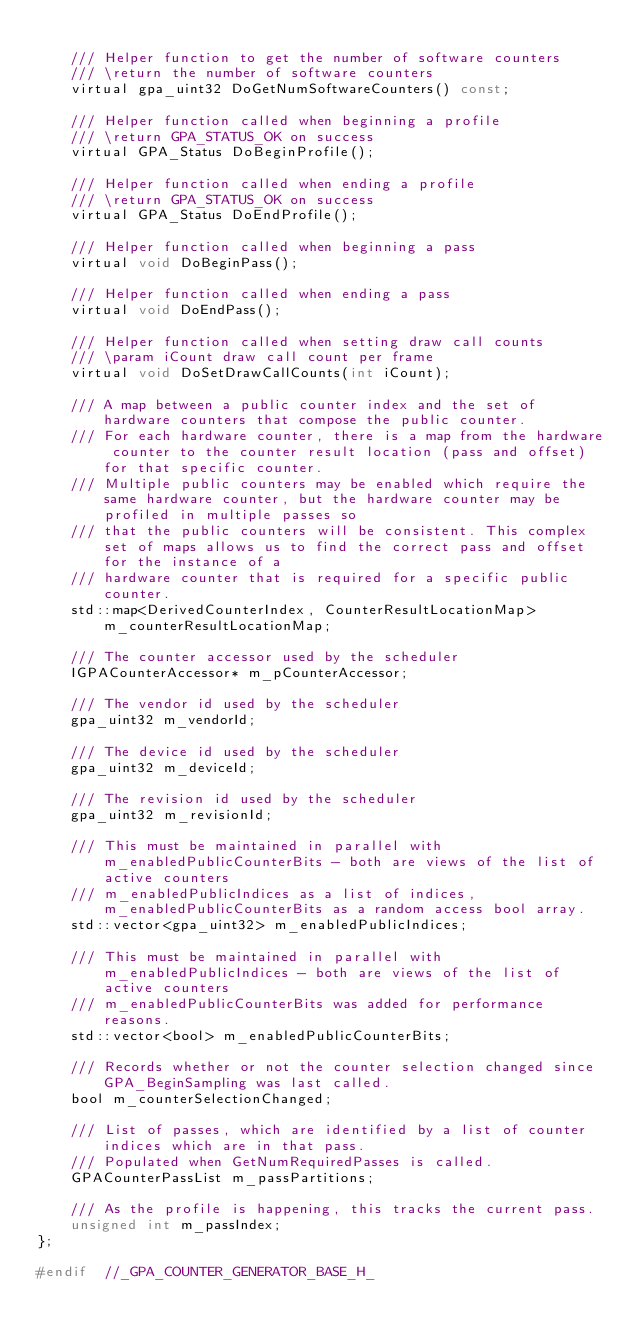Convert code to text. <code><loc_0><loc_0><loc_500><loc_500><_C_>
    /// Helper function to get the number of software counters
    /// \return the number of software counters
    virtual gpa_uint32 DoGetNumSoftwareCounters() const;

    /// Helper function called when beginning a profile
    /// \return GPA_STATUS_OK on success
    virtual GPA_Status DoBeginProfile();

    /// Helper function called when ending a profile
    /// \return GPA_STATUS_OK on success
    virtual GPA_Status DoEndProfile();

    /// Helper function called when beginning a pass
    virtual void DoBeginPass();

    /// Helper function called when ending a pass
    virtual void DoEndPass();

    /// Helper function called when setting draw call counts
    /// \param iCount draw call count per frame
    virtual void DoSetDrawCallCounts(int iCount);

    /// A map between a public counter index and the set of hardware counters that compose the public counter.
    /// For each hardware counter, there is a map from the hardware counter to the counter result location (pass and offset) for that specific counter.
    /// Multiple public counters may be enabled which require the same hardware counter, but the hardware counter may be profiled in multiple passes so
    /// that the public counters will be consistent. This complex set of maps allows us to find the correct pass and offset for the instance of a
    /// hardware counter that is required for a specific public counter.
    std::map<DerivedCounterIndex, CounterResultLocationMap> m_counterResultLocationMap;

    /// The counter accessor used by the scheduler
    IGPACounterAccessor* m_pCounterAccessor;

    /// The vendor id used by the scheduler
    gpa_uint32 m_vendorId;

    /// The device id used by the scheduler
    gpa_uint32 m_deviceId;

    /// The revision id used by the scheduler
    gpa_uint32 m_revisionId;

    /// This must be maintained in parallel with m_enabledPublicCounterBits - both are views of the list of active counters
    /// m_enabledPublicIndices as a list of indices, m_enabledPublicCounterBits as a random access bool array.
    std::vector<gpa_uint32> m_enabledPublicIndices;

    /// This must be maintained in parallel with m_enabledPublicIndices - both are views of the list of active counters
    /// m_enabledPublicCounterBits was added for performance reasons.
    std::vector<bool> m_enabledPublicCounterBits;

    /// Records whether or not the counter selection changed since GPA_BeginSampling was last called.
    bool m_counterSelectionChanged;

    /// List of passes, which are identified by a list of counter indices which are in that pass.
    /// Populated when GetNumRequiredPasses is called.
    GPACounterPassList m_passPartitions;

    /// As the profile is happening, this tracks the current pass.
    unsigned int m_passIndex;
};

#endif  //_GPA_COUNTER_GENERATOR_BASE_H_
</code> 